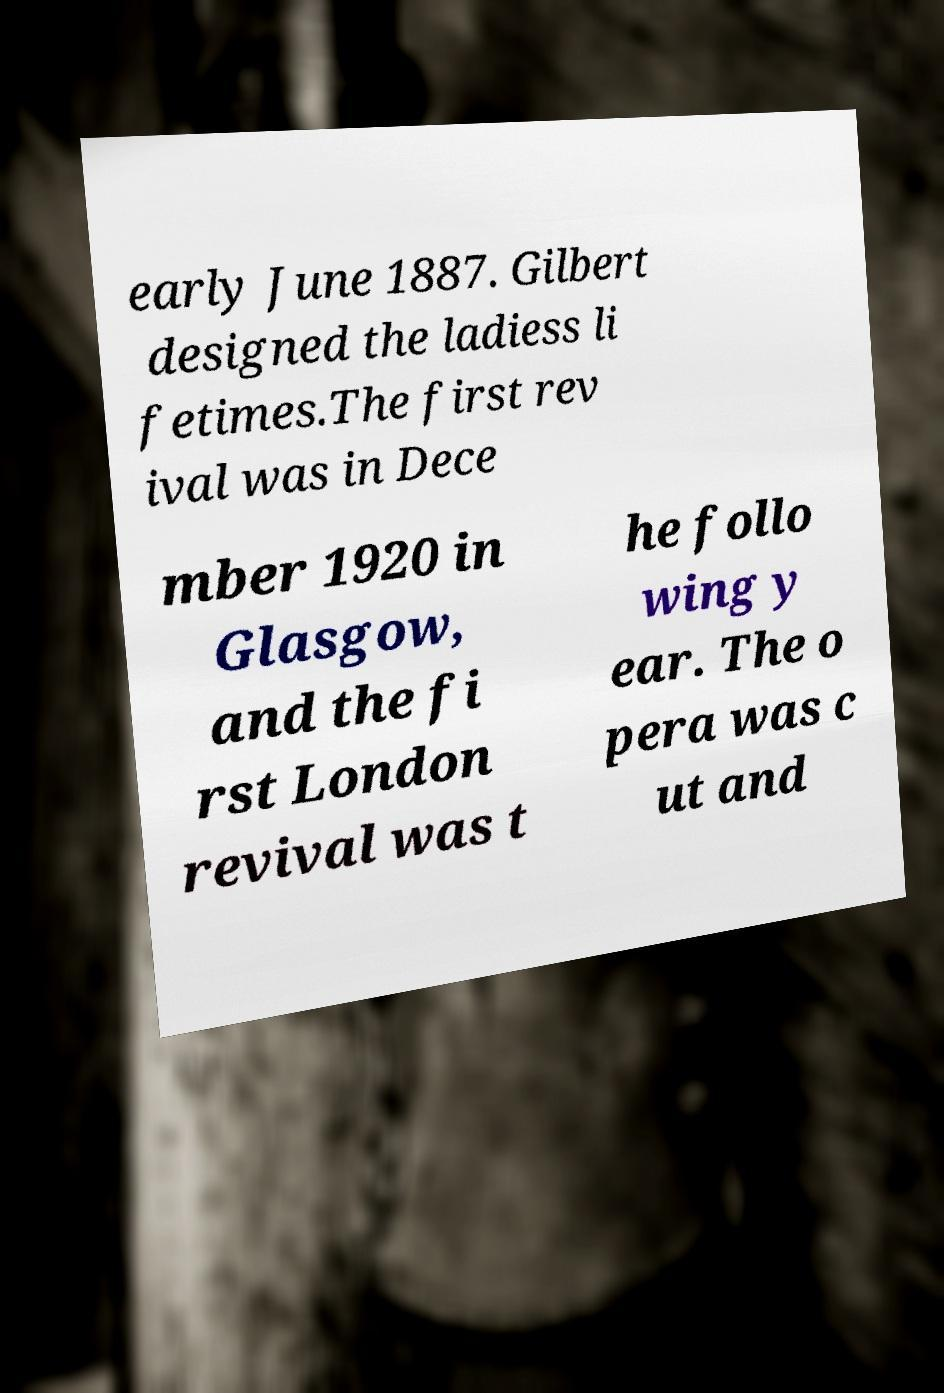I need the written content from this picture converted into text. Can you do that? early June 1887. Gilbert designed the ladiess li fetimes.The first rev ival was in Dece mber 1920 in Glasgow, and the fi rst London revival was t he follo wing y ear. The o pera was c ut and 